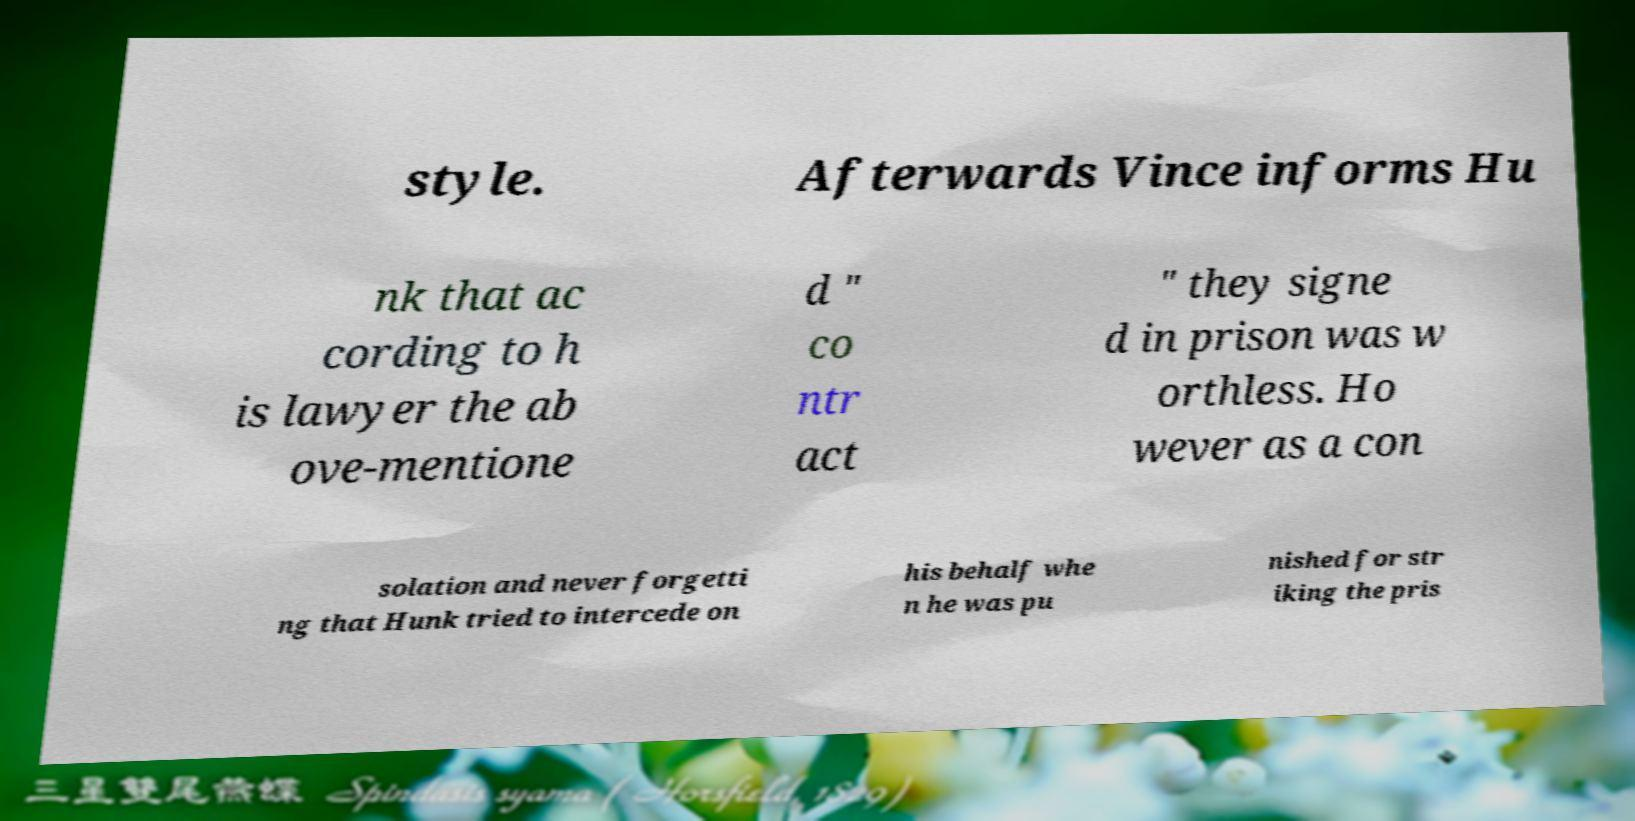Can you accurately transcribe the text from the provided image for me? style. Afterwards Vince informs Hu nk that ac cording to h is lawyer the ab ove-mentione d " co ntr act " they signe d in prison was w orthless. Ho wever as a con solation and never forgetti ng that Hunk tried to intercede on his behalf whe n he was pu nished for str iking the pris 